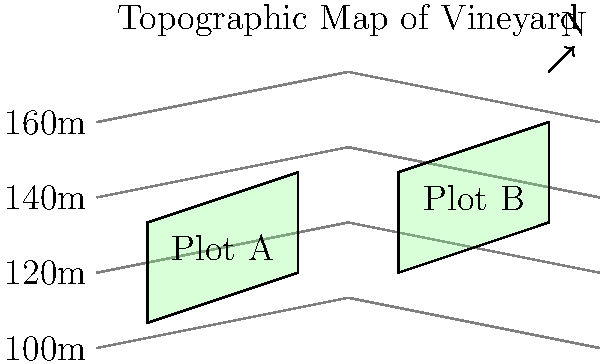As a vineyard owner in Napa Valley, you're analyzing two potential vineyard plots (A and B) using the provided topographic map. Which plot has a steeper slope and is likely to receive more direct sunlight throughout the day? Explain your reasoning based on the contour lines and orientation of the plots. To determine which plot has a steeper slope and is likely to receive more direct sunlight, we need to analyze the contour lines and orientation of each plot:

1. Analyzing slope:
   - Plot A: The contour lines are spaced further apart, indicating a gentler slope.
   - Plot B: The contour lines are closer together, indicating a steeper slope.

   Slope calculation:
   $$ \text{Slope} = \frac{\text{Rise}}{\text{Run}} $$
   
   For Plot A: $\frac{20\text{m}}{60\text{m}} \approx 0.33$ or 33%
   For Plot B: $\frac{40\text{m}}{60\text{m}} \approx 0.67$ or 67%

2. Analyzing sun exposure:
   - Plot A is on a west-facing slope (assuming north is up on the map).
   - Plot B is on an east-facing slope.

   East-facing slopes receive more direct morning sunlight, while west-facing slopes receive more direct afternoon sunlight. In viticulture, east-facing slopes are generally preferred as they allow grapes to warm up earlier in the day and dry faster after morning dew or rain, reducing the risk of fungal diseases.

3. Considering the combination of slope and orientation:
   - Plot B has a steeper slope, which can lead to better drainage and increased sun exposure due to the angle of the land relative to the sun's path.
   - The east-facing orientation of Plot B provides more beneficial morning sunlight for grape cultivation.

Therefore, Plot B has a steeper slope and is likely to receive more direct sunlight throughout the day, making it potentially more suitable for vineyard cultivation.
Answer: Plot B: steeper slope (67% vs. 33%) and east-facing for better morning sun exposure. 